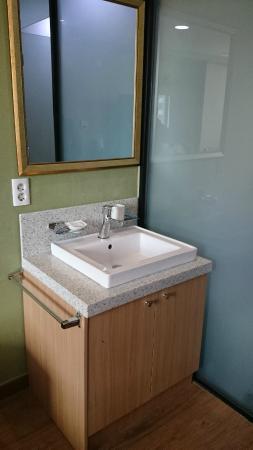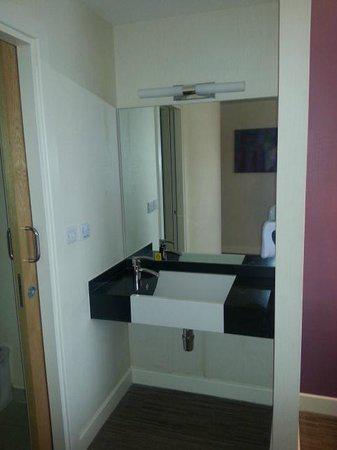The first image is the image on the left, the second image is the image on the right. Given the left and right images, does the statement "One image features a square white sink under a mirror with a counter that spans its tight stall space and does not have a counter beneath it." hold true? Answer yes or no. Yes. The first image is the image on the left, the second image is the image on the right. For the images shown, is this caption "In at least one image there is a raised circle basin sink with a mirror behind it." true? Answer yes or no. No. 